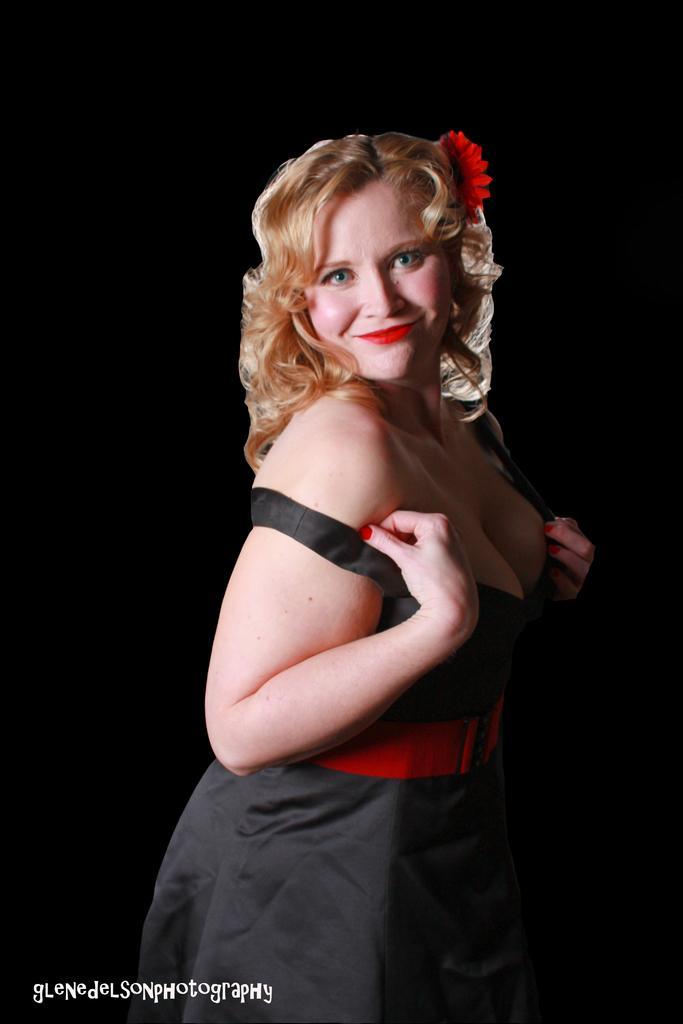Describe this image in one or two sentences. In this image we can see a woman standing. 